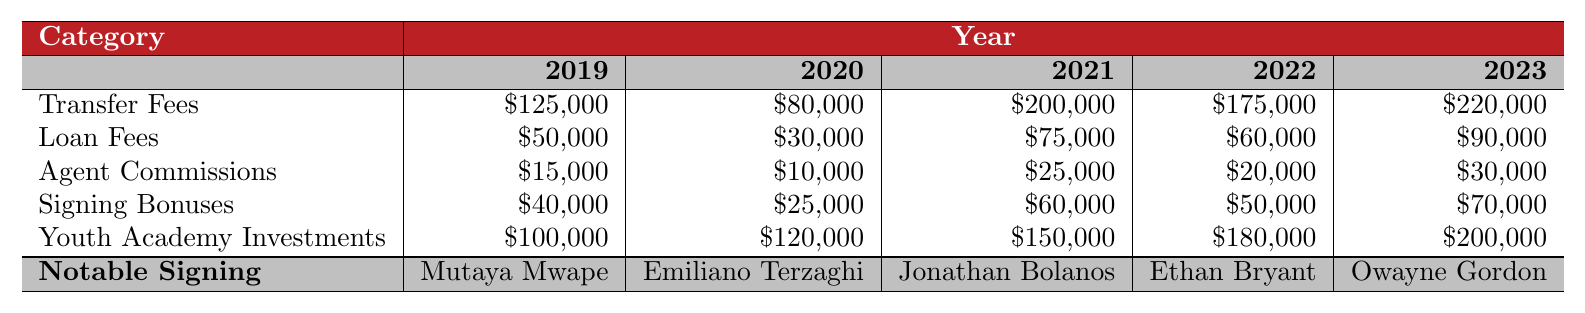What's the total transfer fees spent in 2023? The transfer fee in 2023 is $220,000. There are no additional fees to sum for this category in that year.
Answer: $220,000 What was the loan fees expenditure in 2020? The loan fees for 2020 is $30,000 as noted in the table under that year.
Answer: $30,000 What is the average signing bonus over the last five years? The signing bonuses over the five years are $40,000, $25,000, $60,000, $50,000, and $70,000. The total is $245,000, and the average is $245,000 divided by 5, which equals $49,000.
Answer: $49,000 Which year had the highest youth academy investment? Looking at the youth academy investments for each year, they are $100,000 (2019), $120,000 (2020), $150,000 (2021), $180,000 (2022), and $200,000 (2023). The highest is $200,000 in 2023.
Answer: 2023 Did the agent commissions increase from 2019 to 2023? The agent commissions for 2019 is $15,000 and for 2023 is $30,000. Since $30,000 is greater than $15,000, it can be said that the agent commissions increased.
Answer: Yes What was the total expenditure on loan fees over the last five years? The loan fees over the five years are $50,000 (2019), $30,000 (2020), $75,000 (2021), $60,000 (2022), and $90,000 (2023). Summing these gives $50,000 + $30,000 + $75,000 + $60,000 + $90,000 = $305,000.
Answer: $305,000 Which category had the highest total expenditure over the five years? We need to sum each category: Transfer Fees = $125,000 + $80,000 + $200,000 + $175,000 + $220,000 = $900,000; Loan Fees = $50,000 + $30,000 + $75,000 + $60,000 + $90,000 = $305,000; Agent Commissions = $15,000 + $10,000 + $25,000 + $20,000 + $30,000 = $100,000; Signing Bonuses = $40,000 + $25,000 + $60,000 + $50,000 + $70,000 = $245,000; Youth Academy Investments = $100,000 + $120,000 + $150,000 + $180,000 + $200,000 = $850,000. The highest total is for Transfer Fees at $900,000.
Answer: Transfer Fees In which year was the signing of Emiliano Terzaghi made? The table lists that Emiliano Terzaghi was signed in 2020.
Answer: 2020 What is the difference in total transfer fees between 2021 and 2022? The transfer fees for 2021 is $200,000 and for 2022 is $175,000. The difference is $200,000 - $175,000 = $25,000.
Answer: $25,000 How much did the Richmond Kickers spend in total on youth academy investments over the last five years? The youth academy investments are $100,000 (2019), $120,000 (2020), $150,000 (2021), $180,000 (2022), and $200,000 (2023). Adding these values gives $100,000 + $120,000 + $150,000 + $180,000 + $200,000 = $850,000.
Answer: $850,000 